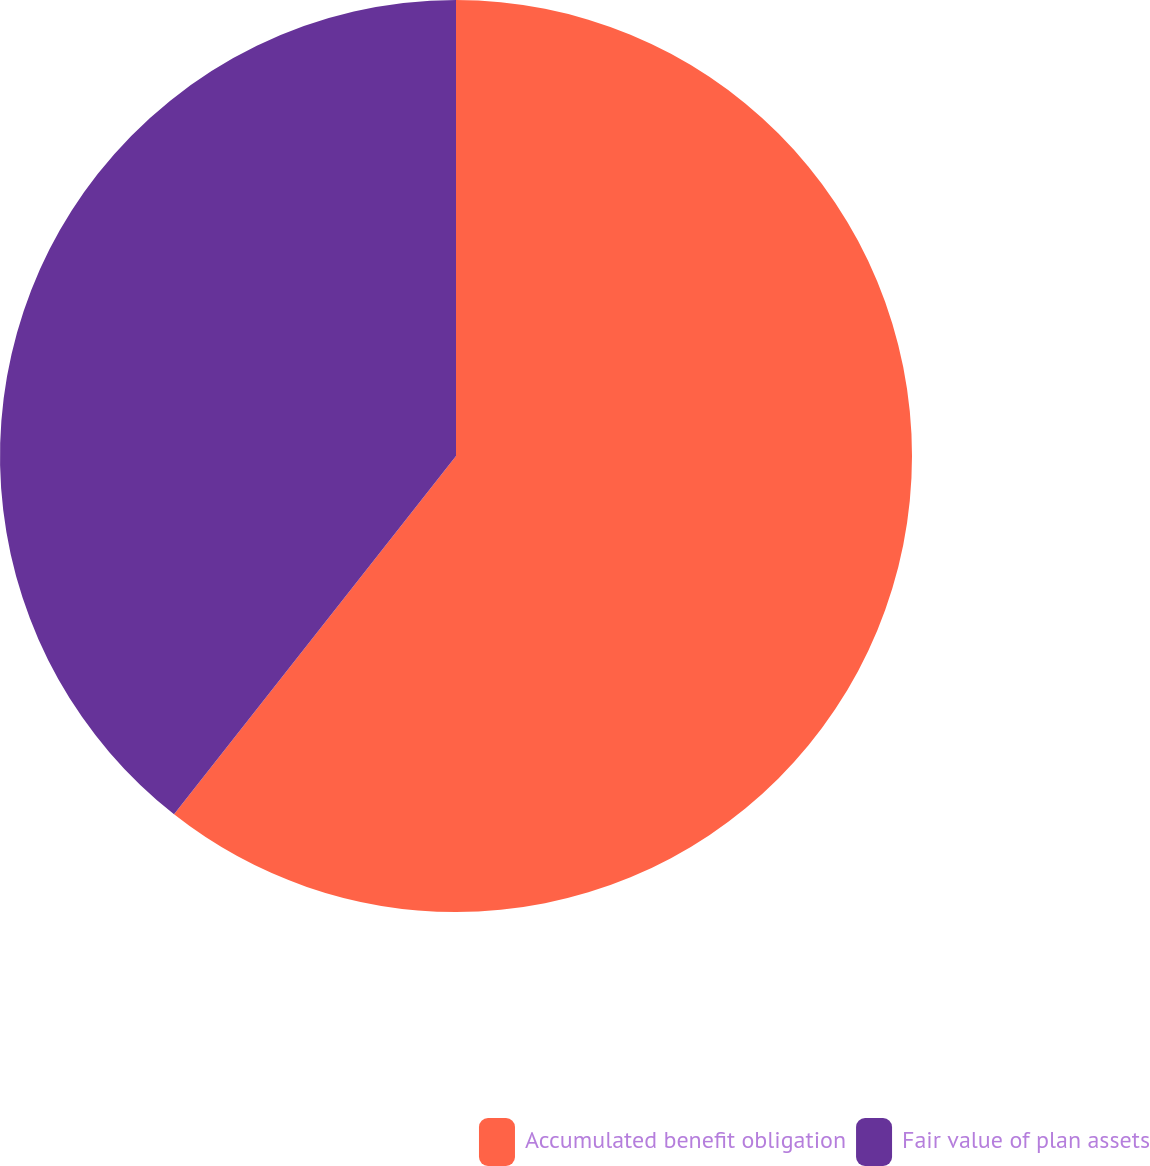Convert chart. <chart><loc_0><loc_0><loc_500><loc_500><pie_chart><fcel>Accumulated benefit obligation<fcel>Fair value of plan assets<nl><fcel>60.61%<fcel>39.39%<nl></chart> 